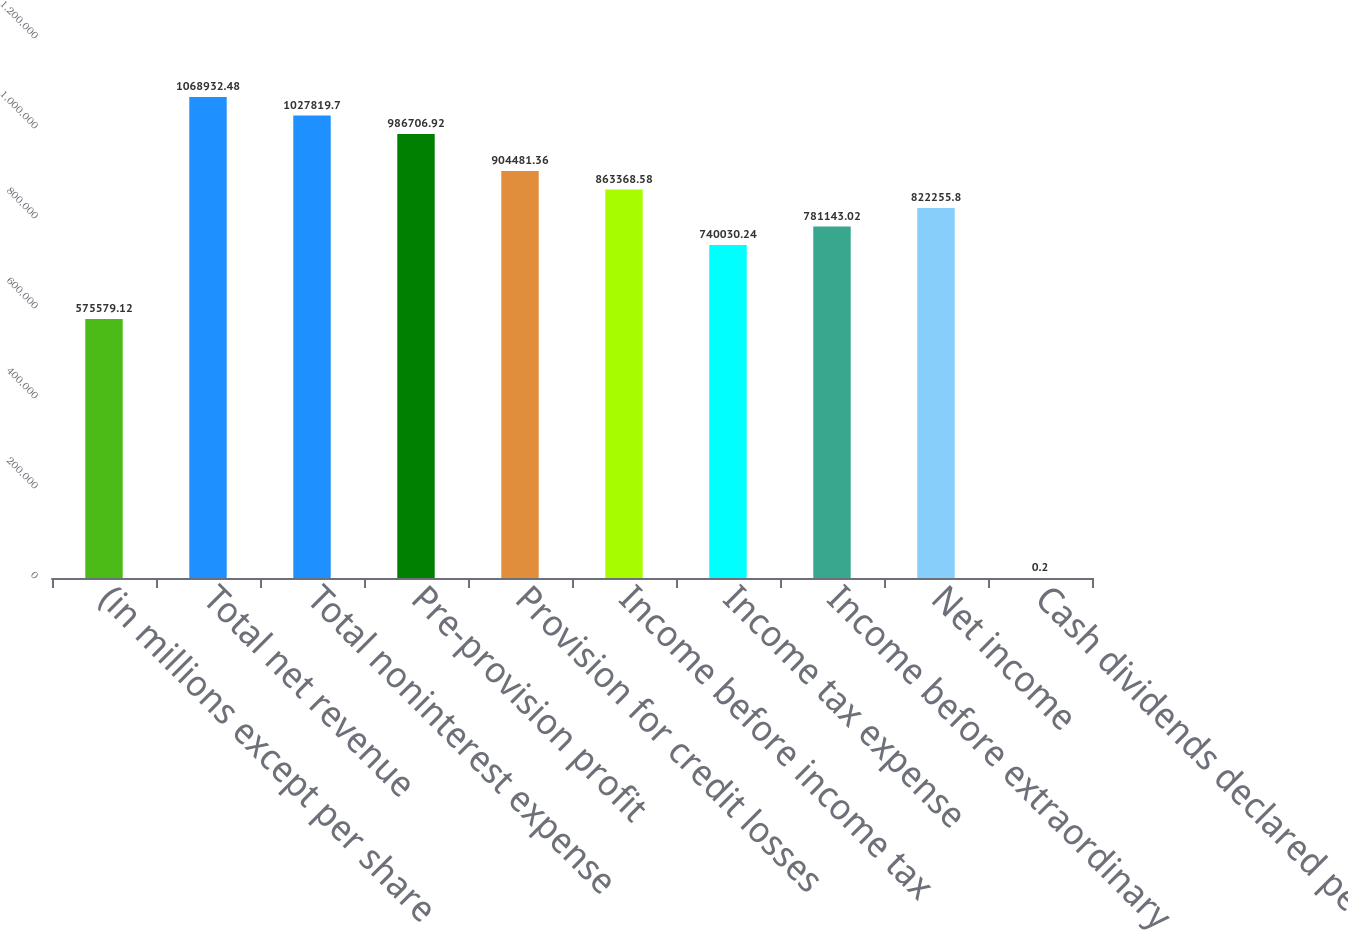<chart> <loc_0><loc_0><loc_500><loc_500><bar_chart><fcel>(in millions except per share<fcel>Total net revenue<fcel>Total noninterest expense<fcel>Pre-provision profit<fcel>Provision for credit losses<fcel>Income before income tax<fcel>Income tax expense<fcel>Income before extraordinary<fcel>Net income<fcel>Cash dividends declared per<nl><fcel>575579<fcel>1.06893e+06<fcel>1.02782e+06<fcel>986707<fcel>904481<fcel>863369<fcel>740030<fcel>781143<fcel>822256<fcel>0.2<nl></chart> 